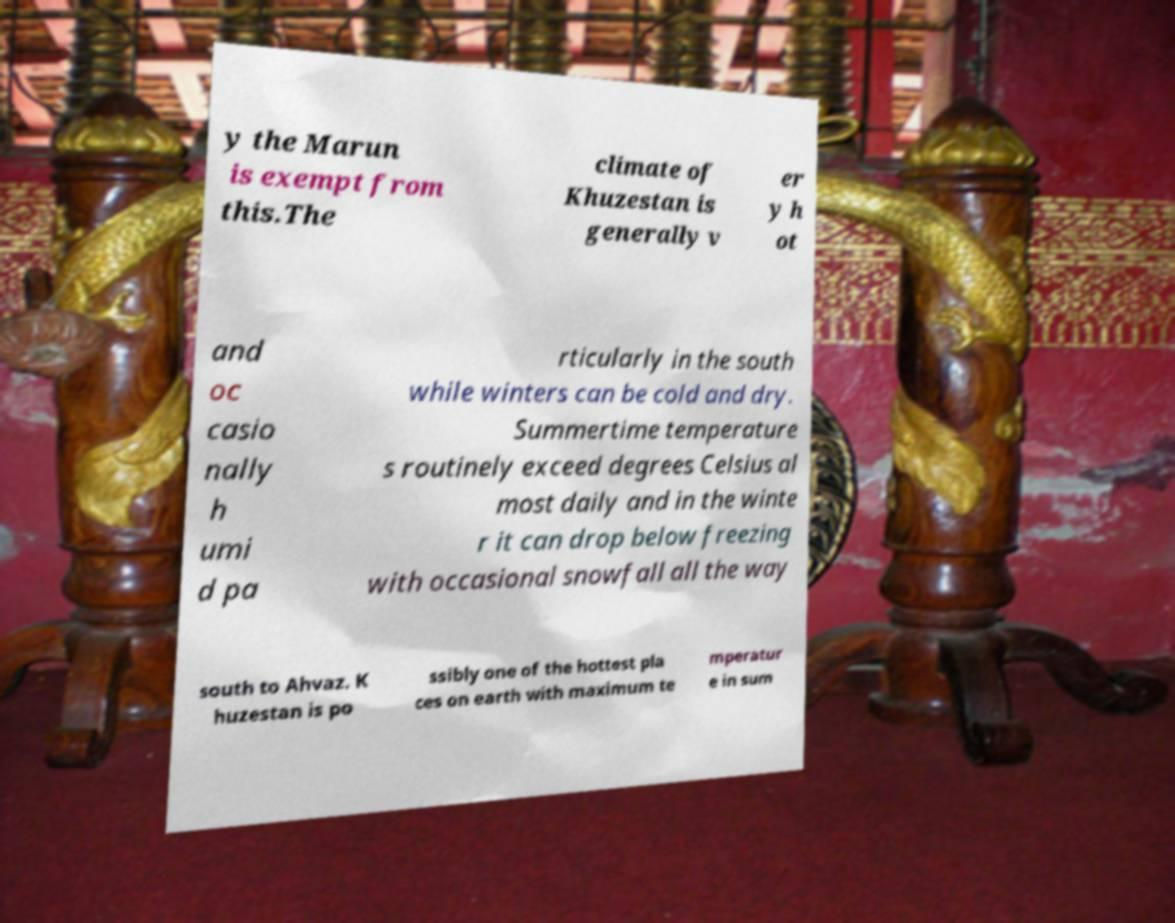What messages or text are displayed in this image? I need them in a readable, typed format. y the Marun is exempt from this.The climate of Khuzestan is generally v er y h ot and oc casio nally h umi d pa rticularly in the south while winters can be cold and dry. Summertime temperature s routinely exceed degrees Celsius al most daily and in the winte r it can drop below freezing with occasional snowfall all the way south to Ahvaz. K huzestan is po ssibly one of the hottest pla ces on earth with maximum te mperatur e in sum 